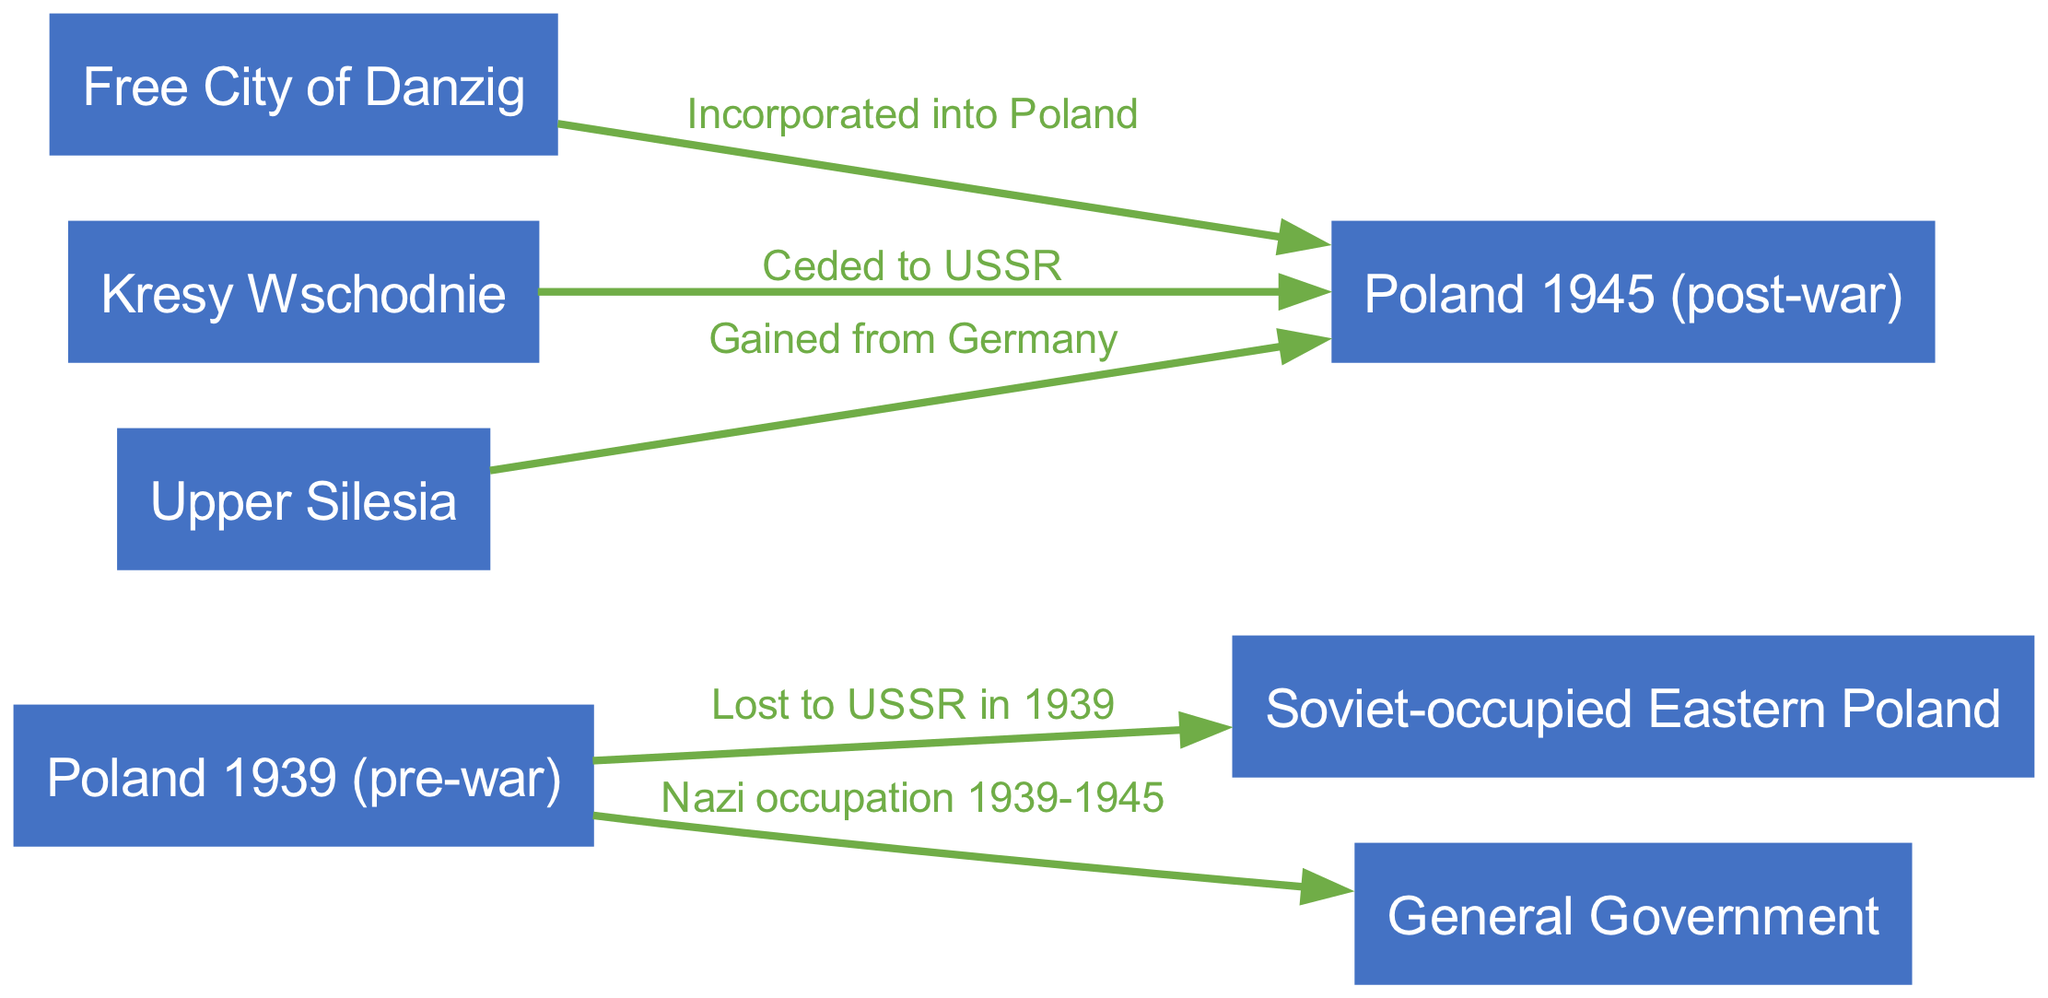What year did Poland lose territory to the USSR? The diagram indicates that Poland lost territory to the USSR in 1939, as shown by the edge labeled "Lost to USSR in 1939" leading from "Poland 1939 (pre-war)" to "Soviet-occupied Eastern Poland."
Answer: 1939 What is the label for the territory occupied by Nazis from 1939 to 1945? The diagram shows that from 1939 to 1945, the territory occupied by Nazis is labeled "General Government," which connects from "Poland 1939 (pre-war)."
Answer: General Government Which territories were ceded to the USSR after the war? According to the diagram, the territory labeled "Kresy Wschodnie" was ceded to the USSR post-war, indicated by the edge connecting it to "Poland 1945 (post-war)" with the label "Ceded to USSR."
Answer: Kresy Wschodnie What territory was incorporated into Poland after World War II? The diagram clearly indicates that the "Free City of Danzig" was incorporated into Poland, as shown by the edge labeled "Incorporated into Poland" leading to "Poland 1945 (post-war)."
Answer: Free City of Danzig What was gained from Germany after World War II? The edge in the diagram specifies that "Upper Silesia" was gained from Germany after the war, indicated by the label "Gained from Germany" linking it to "Poland 1945 (post-war)."
Answer: Upper Silesia How many total nodes are present in the diagram? To find the total nodes, we count each labeled area in the diagram: "Poland 1939 (pre-war)," "Soviet-occupied Eastern Poland," "General Government," "Poland 1945 (post-war)," "Free City of Danzig," "Kresy Wschodnie," and "Upper Silesia," totaling seven nodes.
Answer: 7 What relationship exists between "Poland 1939 (pre-war)" and "General Government"? The diagram shows that "Poland 1939 (pre-war)" is directly related to "General Government" by an edge labeled "Nazi occupation 1939-1945," indicating the occupation of this territory by the Nazis.
Answer: Nazi occupation 1939-1945 Which areas lost land to the USSR during the war? The diagram shows that "Poland 1939 (pre-war)" lost land to the USSR as a whole, with a specific connection to "Soviet-occupied Eastern Poland," indicating the loss of territory.
Answer: Soviet-occupied Eastern Poland 